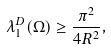Convert formula to latex. <formula><loc_0><loc_0><loc_500><loc_500>\lambda _ { 1 } ^ { D } ( \Omega ) \geq \frac { \pi ^ { 2 } } { 4 R ^ { 2 } } ,</formula> 